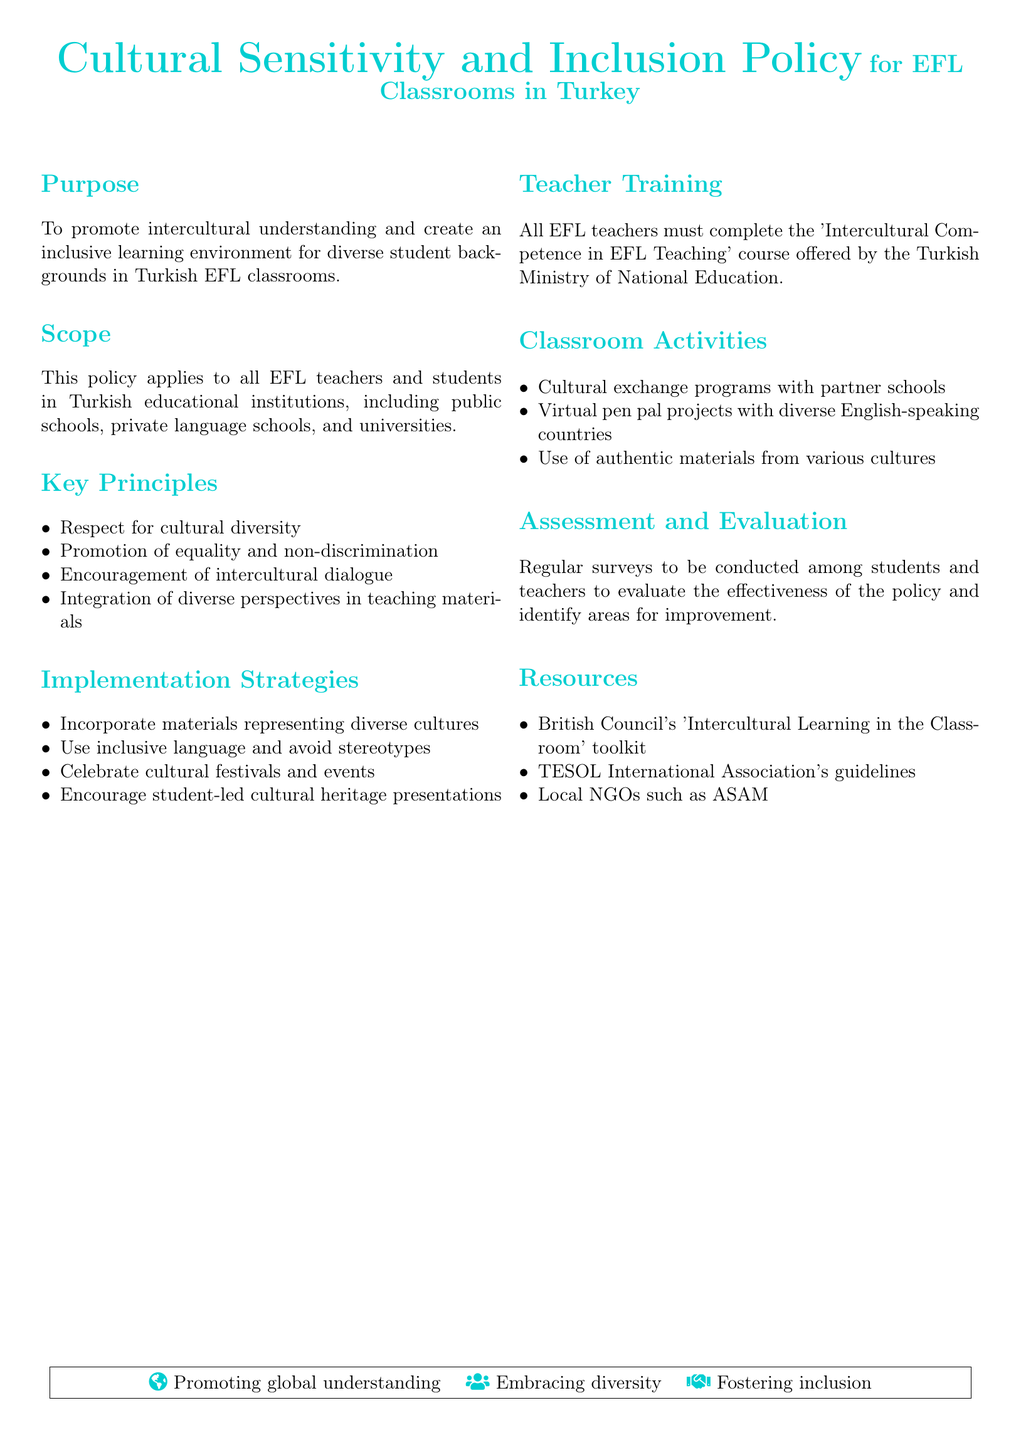What is the purpose of the policy? The purpose of the policy is to promote intercultural understanding and create an inclusive learning environment for diverse student backgrounds in Turkish EFL classrooms.
Answer: To promote intercultural understanding and create an inclusive learning environment What is the scope of the policy? The scope of the policy includes all EFL teachers and students in Turkish educational institutions.
Answer: All EFL teachers and students in Turkish educational institutions What is the first key principle mentioned? The first key principle in the document focuses on cultural diversity.
Answer: Respect for cultural diversity Which course must EFL teachers complete? The policy requires EFL teachers to complete the 'Intercultural Competence in EFL Teaching' course.
Answer: 'Intercultural Competence in EFL Teaching' What is one implementation strategy listed in the policy? The policy lists incorporating materials representing diverse cultures as a strategy.
Answer: Incorporate materials representing diverse cultures How often are surveys conducted for assessment and evaluation? The document mentions that regular surveys are to be conducted.
Answer: Regularly Which organization's toolkit is listed as a resource? The British Council's toolkit is mentioned in the resources.
Answer: British Council's 'Intercultural Learning in the Classroom' toolkit What type of projects are encouraged for classroom activities? The document encourages virtual pen pal projects.
Answer: Virtual pen pal projects What does the document emphasize through its initiatives? The initiatives emphasize fostering inclusion among diverse groups in the classroom.
Answer: Fostering inclusion 